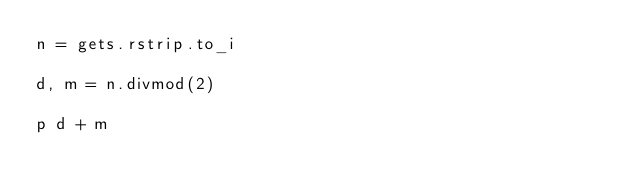Convert code to text. <code><loc_0><loc_0><loc_500><loc_500><_Ruby_>n = gets.rstrip.to_i

d, m = n.divmod(2)

p d + m</code> 